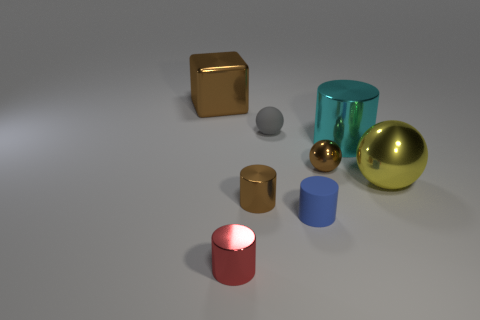Add 2 small cyan spheres. How many objects exist? 10 Subtract all big yellow shiny balls. How many balls are left? 2 Subtract all brown balls. How many balls are left? 2 Add 7 red metallic cylinders. How many red metallic cylinders are left? 8 Add 7 green things. How many green things exist? 7 Subtract 1 brown cylinders. How many objects are left? 7 Subtract all blocks. How many objects are left? 7 Subtract 2 cylinders. How many cylinders are left? 2 Subtract all blue cylinders. Subtract all purple spheres. How many cylinders are left? 3 Subtract all cyan spheres. How many brown cylinders are left? 1 